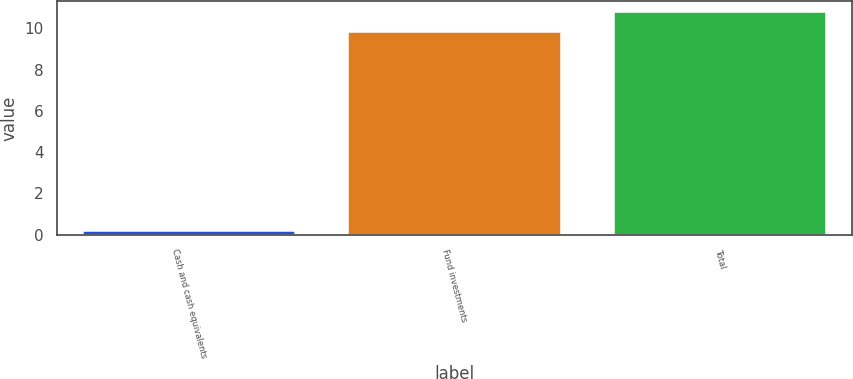Convert chart to OTSL. <chart><loc_0><loc_0><loc_500><loc_500><bar_chart><fcel>Cash and cash equivalents<fcel>Fund investments<fcel>Total<nl><fcel>0.2<fcel>9.8<fcel>10.78<nl></chart> 